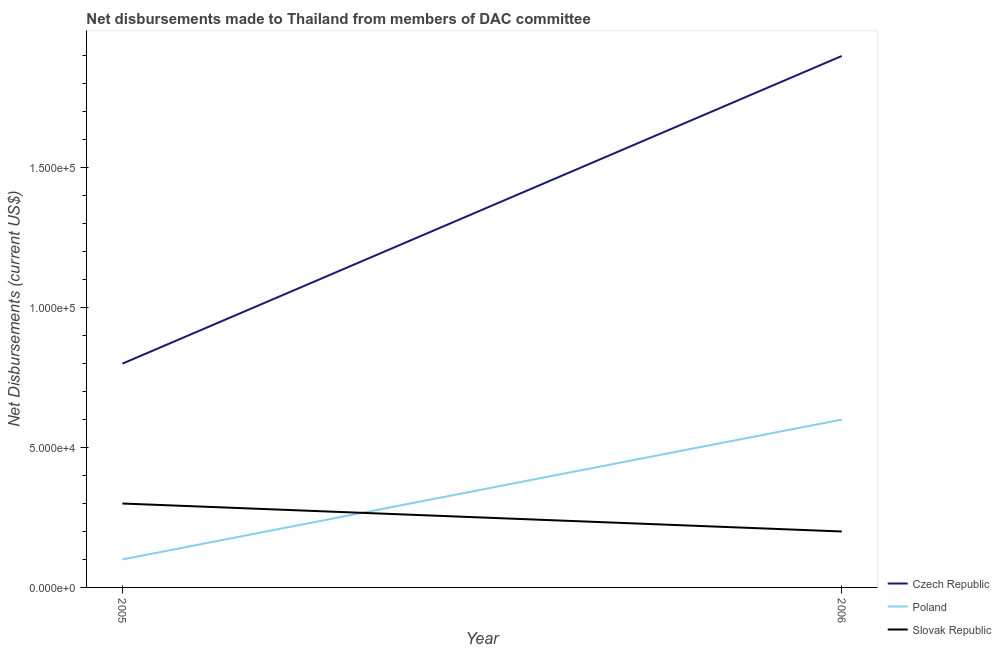How many different coloured lines are there?
Your answer should be compact. 3. Does the line corresponding to net disbursements made by poland intersect with the line corresponding to net disbursements made by slovak republic?
Offer a terse response. Yes. What is the net disbursements made by czech republic in 2005?
Keep it short and to the point. 8.00e+04. Across all years, what is the maximum net disbursements made by slovak republic?
Provide a short and direct response. 3.00e+04. Across all years, what is the minimum net disbursements made by slovak republic?
Ensure brevity in your answer.  2.00e+04. In which year was the net disbursements made by poland maximum?
Provide a succinct answer. 2006. What is the total net disbursements made by czech republic in the graph?
Keep it short and to the point. 2.70e+05. What is the difference between the net disbursements made by poland in 2005 and that in 2006?
Your response must be concise. -5.00e+04. What is the difference between the net disbursements made by czech republic in 2006 and the net disbursements made by slovak republic in 2005?
Your answer should be very brief. 1.60e+05. What is the average net disbursements made by czech republic per year?
Make the answer very short. 1.35e+05. In the year 2006, what is the difference between the net disbursements made by poland and net disbursements made by slovak republic?
Your answer should be very brief. 4.00e+04. In how many years, is the net disbursements made by poland greater than 50000 US$?
Offer a terse response. 1. What is the ratio of the net disbursements made by czech republic in 2005 to that in 2006?
Offer a terse response. 0.42. Is the net disbursements made by czech republic in 2005 less than that in 2006?
Provide a succinct answer. Yes. Is it the case that in every year, the sum of the net disbursements made by czech republic and net disbursements made by poland is greater than the net disbursements made by slovak republic?
Ensure brevity in your answer.  Yes. How many lines are there?
Your answer should be very brief. 3. How many years are there in the graph?
Provide a succinct answer. 2. Does the graph contain grids?
Your response must be concise. No. Where does the legend appear in the graph?
Offer a very short reply. Bottom right. How are the legend labels stacked?
Offer a very short reply. Vertical. What is the title of the graph?
Give a very brief answer. Net disbursements made to Thailand from members of DAC committee. Does "Taxes" appear as one of the legend labels in the graph?
Provide a succinct answer. No. What is the label or title of the Y-axis?
Your answer should be very brief. Net Disbursements (current US$). What is the Net Disbursements (current US$) in Poland in 2005?
Your response must be concise. 10000. What is the Net Disbursements (current US$) in Slovak Republic in 2005?
Provide a short and direct response. 3.00e+04. What is the Net Disbursements (current US$) of Poland in 2006?
Offer a very short reply. 6.00e+04. What is the Net Disbursements (current US$) of Slovak Republic in 2006?
Give a very brief answer. 2.00e+04. Across all years, what is the maximum Net Disbursements (current US$) of Czech Republic?
Give a very brief answer. 1.90e+05. Across all years, what is the minimum Net Disbursements (current US$) of Czech Republic?
Offer a terse response. 8.00e+04. Across all years, what is the minimum Net Disbursements (current US$) in Poland?
Your response must be concise. 10000. Across all years, what is the minimum Net Disbursements (current US$) of Slovak Republic?
Your response must be concise. 2.00e+04. What is the total Net Disbursements (current US$) of Czech Republic in the graph?
Your answer should be very brief. 2.70e+05. What is the total Net Disbursements (current US$) in Poland in the graph?
Make the answer very short. 7.00e+04. What is the total Net Disbursements (current US$) of Slovak Republic in the graph?
Your answer should be very brief. 5.00e+04. What is the difference between the Net Disbursements (current US$) of Czech Republic in 2005 and that in 2006?
Keep it short and to the point. -1.10e+05. What is the average Net Disbursements (current US$) of Czech Republic per year?
Your response must be concise. 1.35e+05. What is the average Net Disbursements (current US$) in Poland per year?
Your response must be concise. 3.50e+04. What is the average Net Disbursements (current US$) of Slovak Republic per year?
Offer a terse response. 2.50e+04. In the year 2005, what is the difference between the Net Disbursements (current US$) in Czech Republic and Net Disbursements (current US$) in Poland?
Give a very brief answer. 7.00e+04. In the year 2005, what is the difference between the Net Disbursements (current US$) in Poland and Net Disbursements (current US$) in Slovak Republic?
Your response must be concise. -2.00e+04. In the year 2006, what is the difference between the Net Disbursements (current US$) of Czech Republic and Net Disbursements (current US$) of Slovak Republic?
Provide a short and direct response. 1.70e+05. In the year 2006, what is the difference between the Net Disbursements (current US$) in Poland and Net Disbursements (current US$) in Slovak Republic?
Your response must be concise. 4.00e+04. What is the ratio of the Net Disbursements (current US$) of Czech Republic in 2005 to that in 2006?
Your response must be concise. 0.42. What is the ratio of the Net Disbursements (current US$) of Poland in 2005 to that in 2006?
Your answer should be compact. 0.17. What is the ratio of the Net Disbursements (current US$) of Slovak Republic in 2005 to that in 2006?
Your answer should be very brief. 1.5. What is the difference between the highest and the second highest Net Disbursements (current US$) in Czech Republic?
Keep it short and to the point. 1.10e+05. What is the difference between the highest and the second highest Net Disbursements (current US$) in Poland?
Give a very brief answer. 5.00e+04. What is the difference between the highest and the lowest Net Disbursements (current US$) of Poland?
Provide a short and direct response. 5.00e+04. 